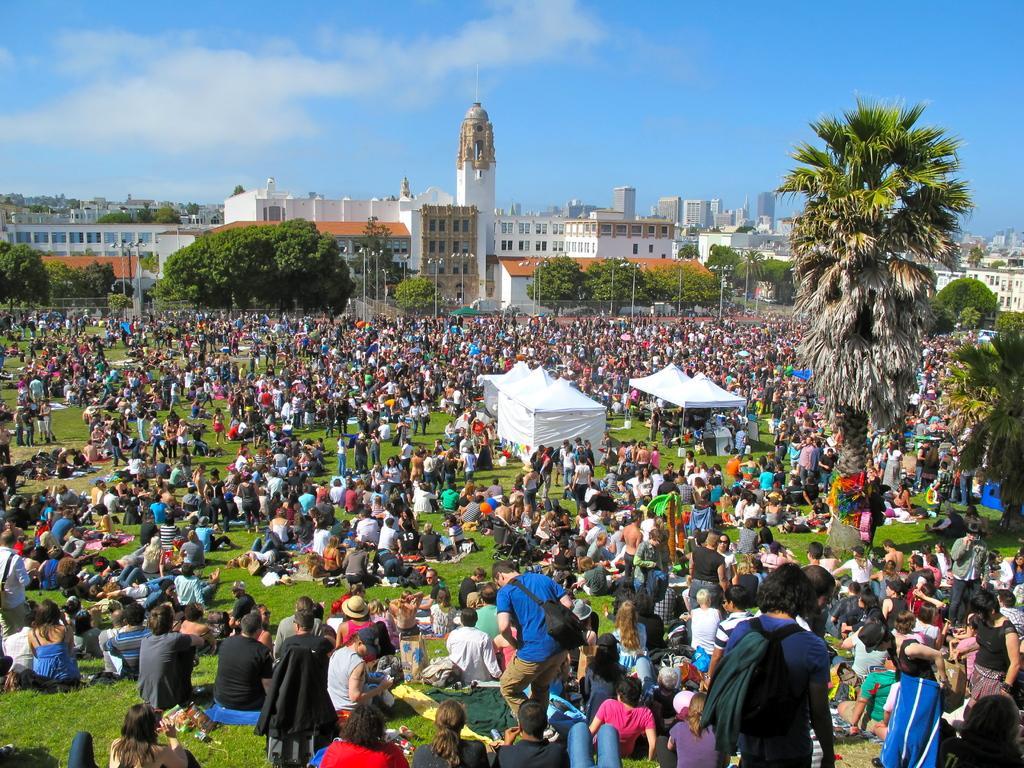Describe this image in one or two sentences. In this picture we can see a group of people sitting on grass, tents, buildings, trees and in the background we can see the sky with clouds. 